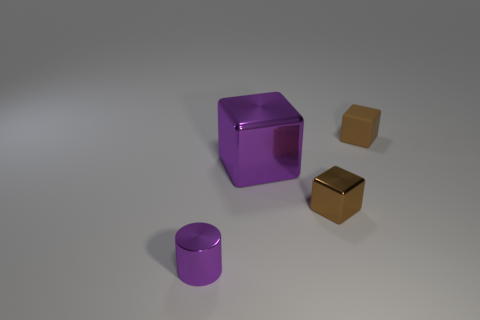What number of metallic things are there?
Make the answer very short. 3. There is a big shiny thing that is on the right side of the tiny purple metallic cylinder; does it have the same color as the metallic thing on the left side of the large shiny block?
Your response must be concise. Yes. What is the size of the shiny cylinder that is the same color as the big metal thing?
Provide a short and direct response. Small. How many other objects are there of the same size as the cylinder?
Provide a short and direct response. 2. What is the color of the tiny matte cube behind the small purple object?
Keep it short and to the point. Brown. Do the tiny thing to the left of the purple metallic block and the large purple block have the same material?
Give a very brief answer. Yes. What number of small things are both behind the tiny purple metallic cylinder and in front of the tiny brown matte block?
Your answer should be very brief. 1. What color is the tiny cube behind the purple thing that is behind the purple thing left of the large purple shiny object?
Ensure brevity in your answer.  Brown. How many other things are there of the same shape as the big shiny thing?
Ensure brevity in your answer.  2. Is there a small metal object to the right of the tiny purple thing in front of the rubber block?
Your response must be concise. Yes. 